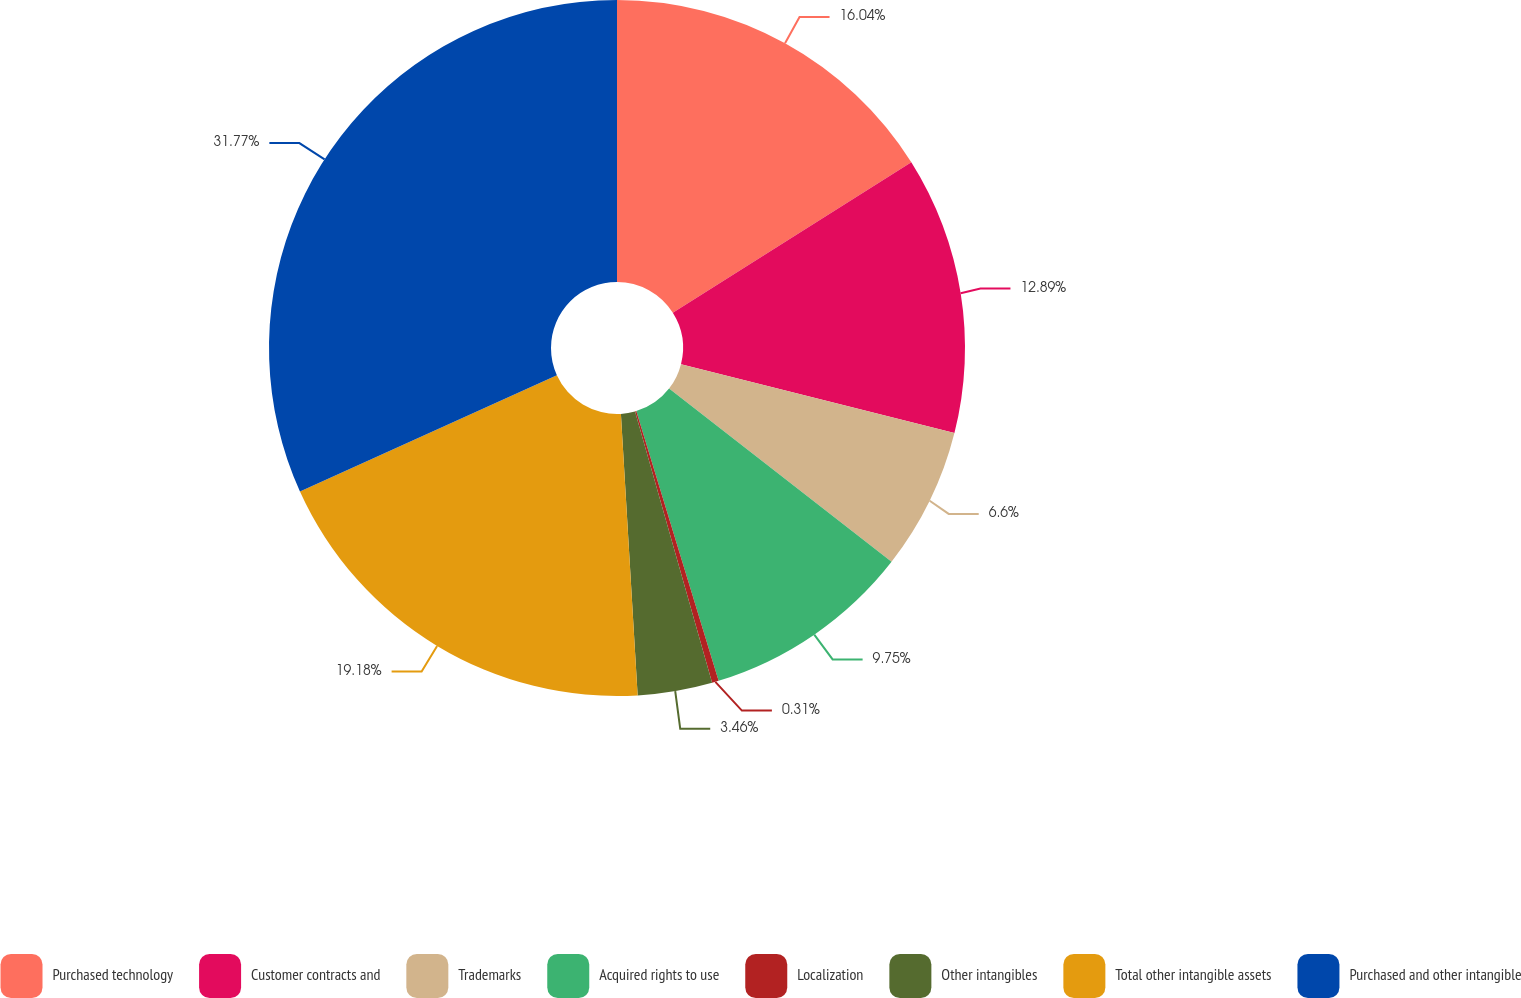Convert chart to OTSL. <chart><loc_0><loc_0><loc_500><loc_500><pie_chart><fcel>Purchased technology<fcel>Customer contracts and<fcel>Trademarks<fcel>Acquired rights to use<fcel>Localization<fcel>Other intangibles<fcel>Total other intangible assets<fcel>Purchased and other intangible<nl><fcel>16.04%<fcel>12.89%<fcel>6.6%<fcel>9.75%<fcel>0.31%<fcel>3.46%<fcel>19.18%<fcel>31.76%<nl></chart> 